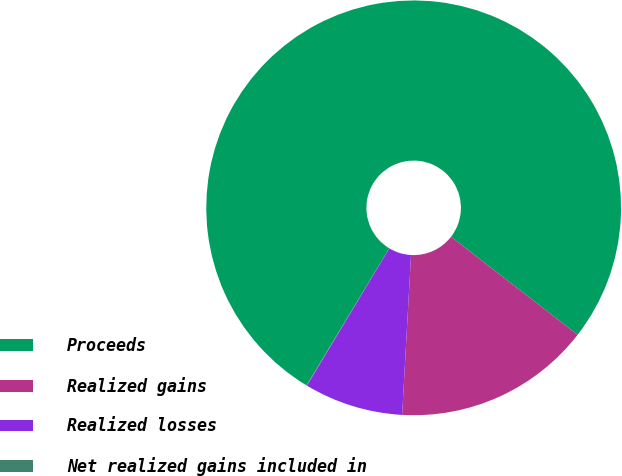Convert chart. <chart><loc_0><loc_0><loc_500><loc_500><pie_chart><fcel>Proceeds<fcel>Realized gains<fcel>Realized losses<fcel>Net realized gains included in<nl><fcel>76.84%<fcel>15.4%<fcel>7.72%<fcel>0.04%<nl></chart> 